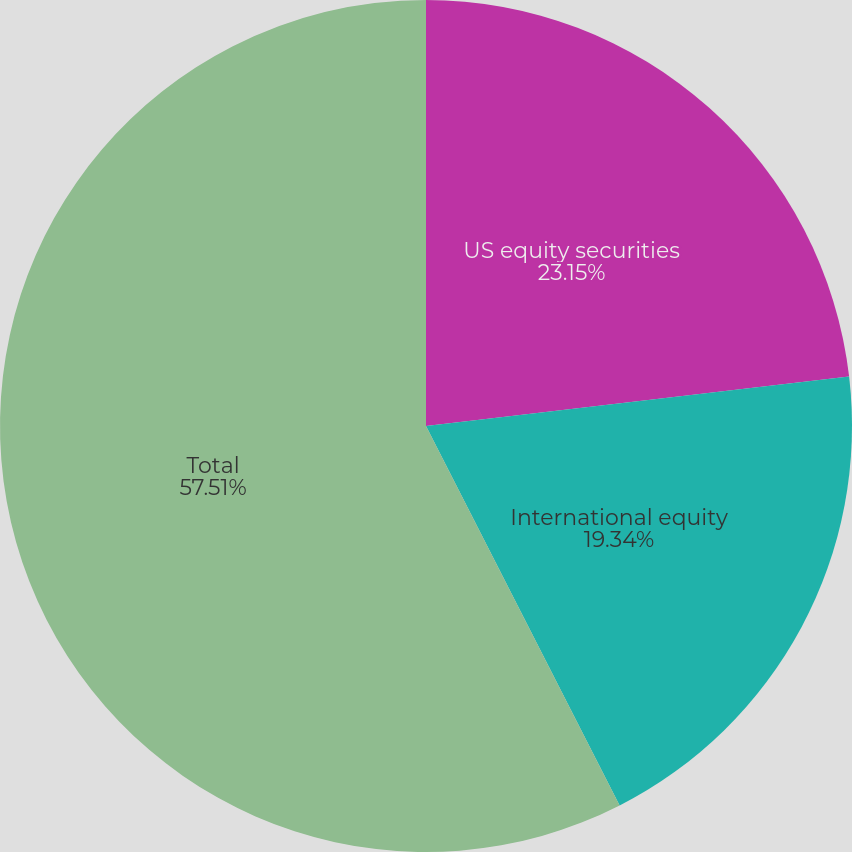<chart> <loc_0><loc_0><loc_500><loc_500><pie_chart><fcel>US equity securities<fcel>International equity<fcel>Total<nl><fcel>23.15%<fcel>19.34%<fcel>57.51%<nl></chart> 